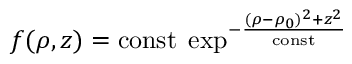<formula> <loc_0><loc_0><loc_500><loc_500>f ( \rho , z ) = c o n s t \, \exp ^ { - { \frac { ( \rho - \rho _ { 0 } ) ^ { 2 } + z ^ { 2 } } { c o n s t } } }</formula> 